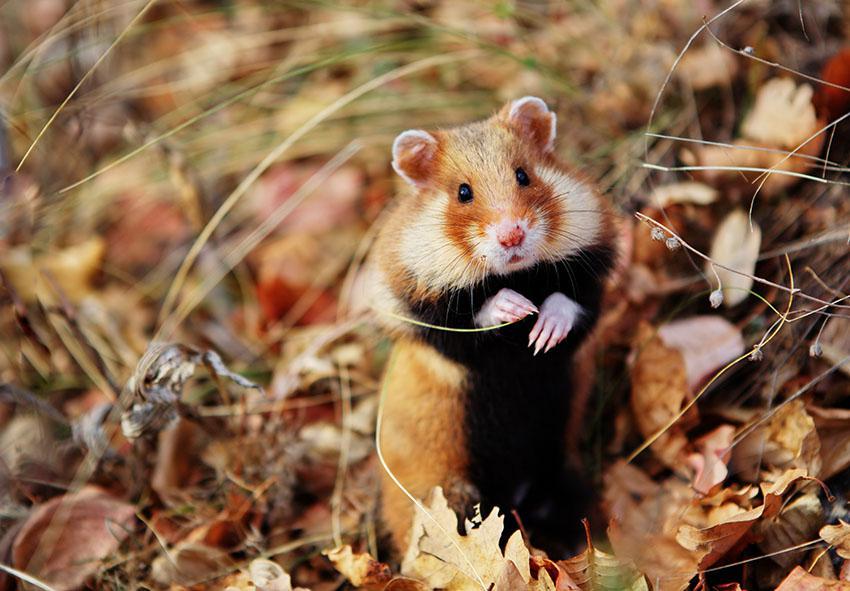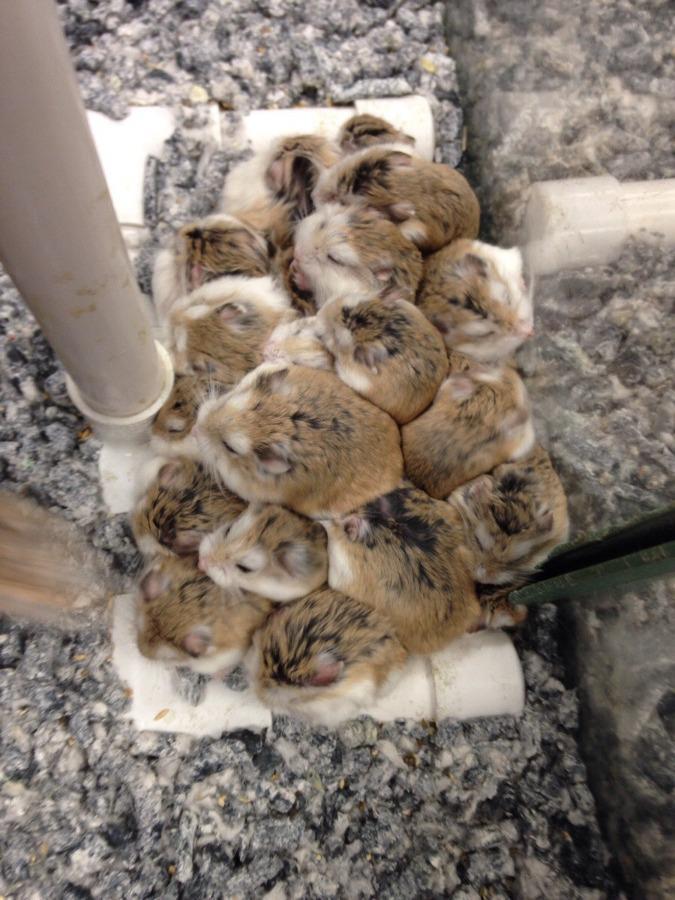The first image is the image on the left, the second image is the image on the right. For the images displayed, is the sentence "There is exactly one rodent in the image on the left." factually correct? Answer yes or no. Yes. 